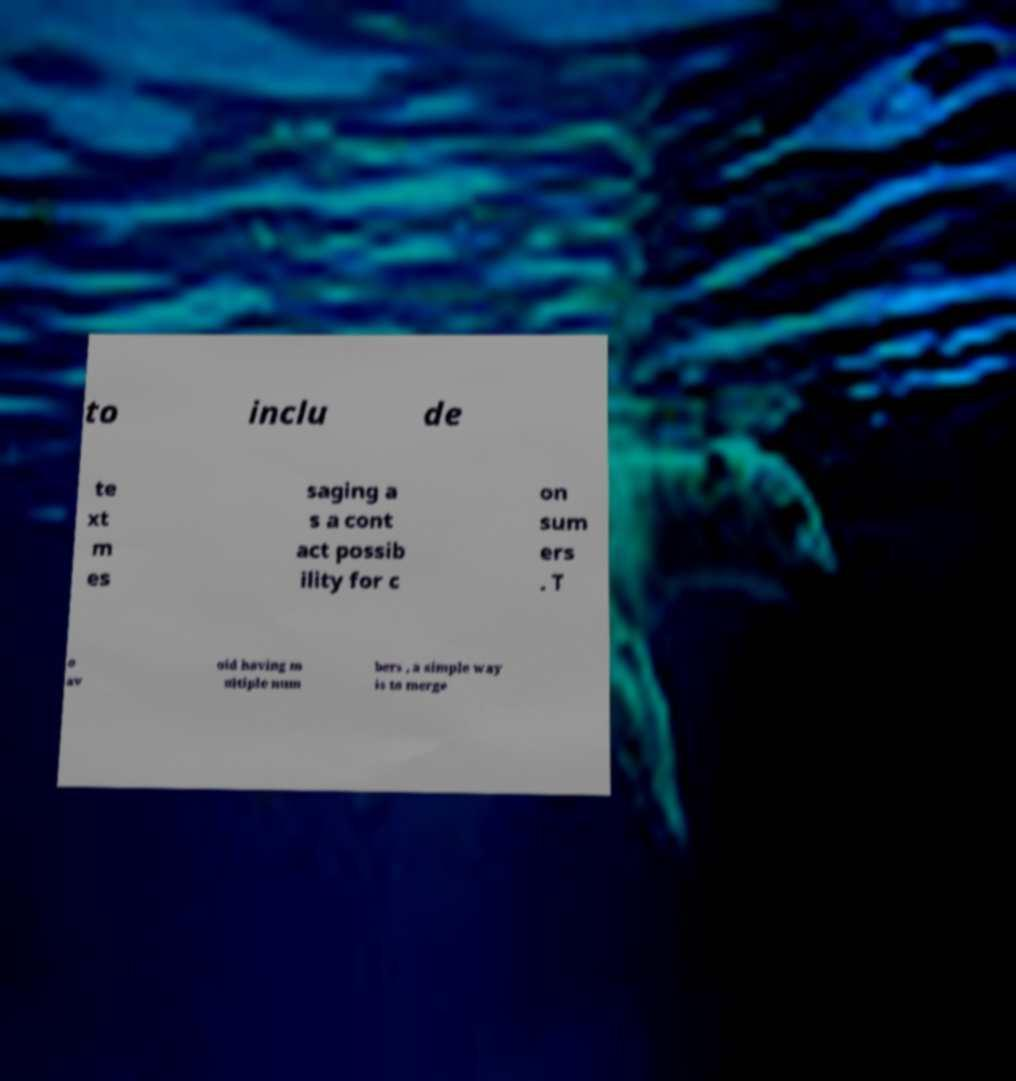Could you assist in decoding the text presented in this image and type it out clearly? to inclu de te xt m es saging a s a cont act possib ility for c on sum ers . T o av oid having m ultiple num bers , a simple way is to merge 